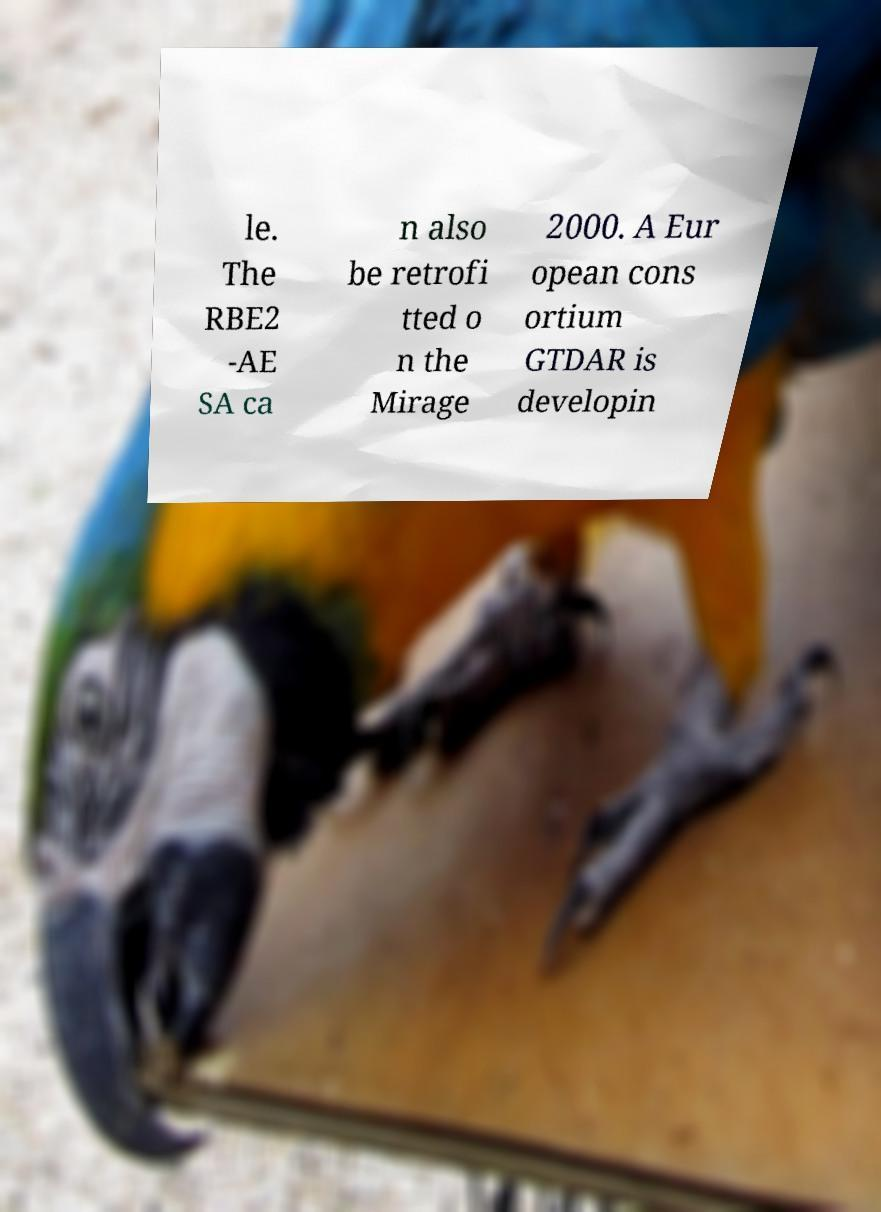Can you read and provide the text displayed in the image?This photo seems to have some interesting text. Can you extract and type it out for me? le. The RBE2 -AE SA ca n also be retrofi tted o n the Mirage 2000. A Eur opean cons ortium GTDAR is developin 